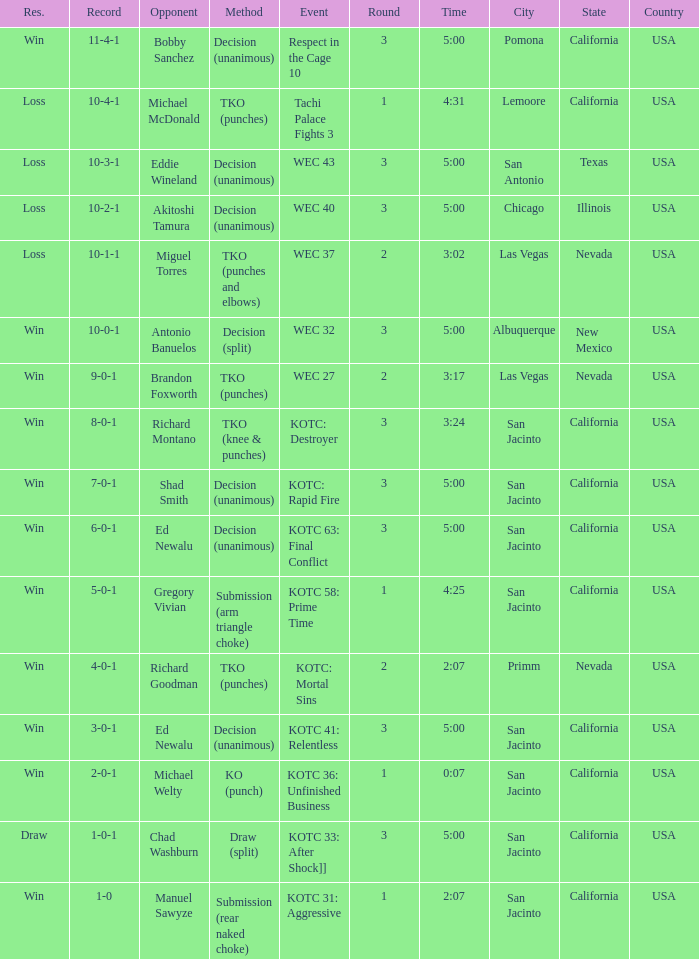What time did the even tachi palace fights 3 take place? 4:31. 